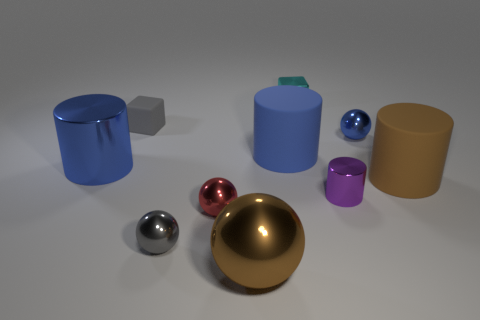What material do the shiny spheres look like they are made of? The shiny spheres give off a reflective appearance, suggesting that they could be made of polished metal or some form of glossy plastic. 